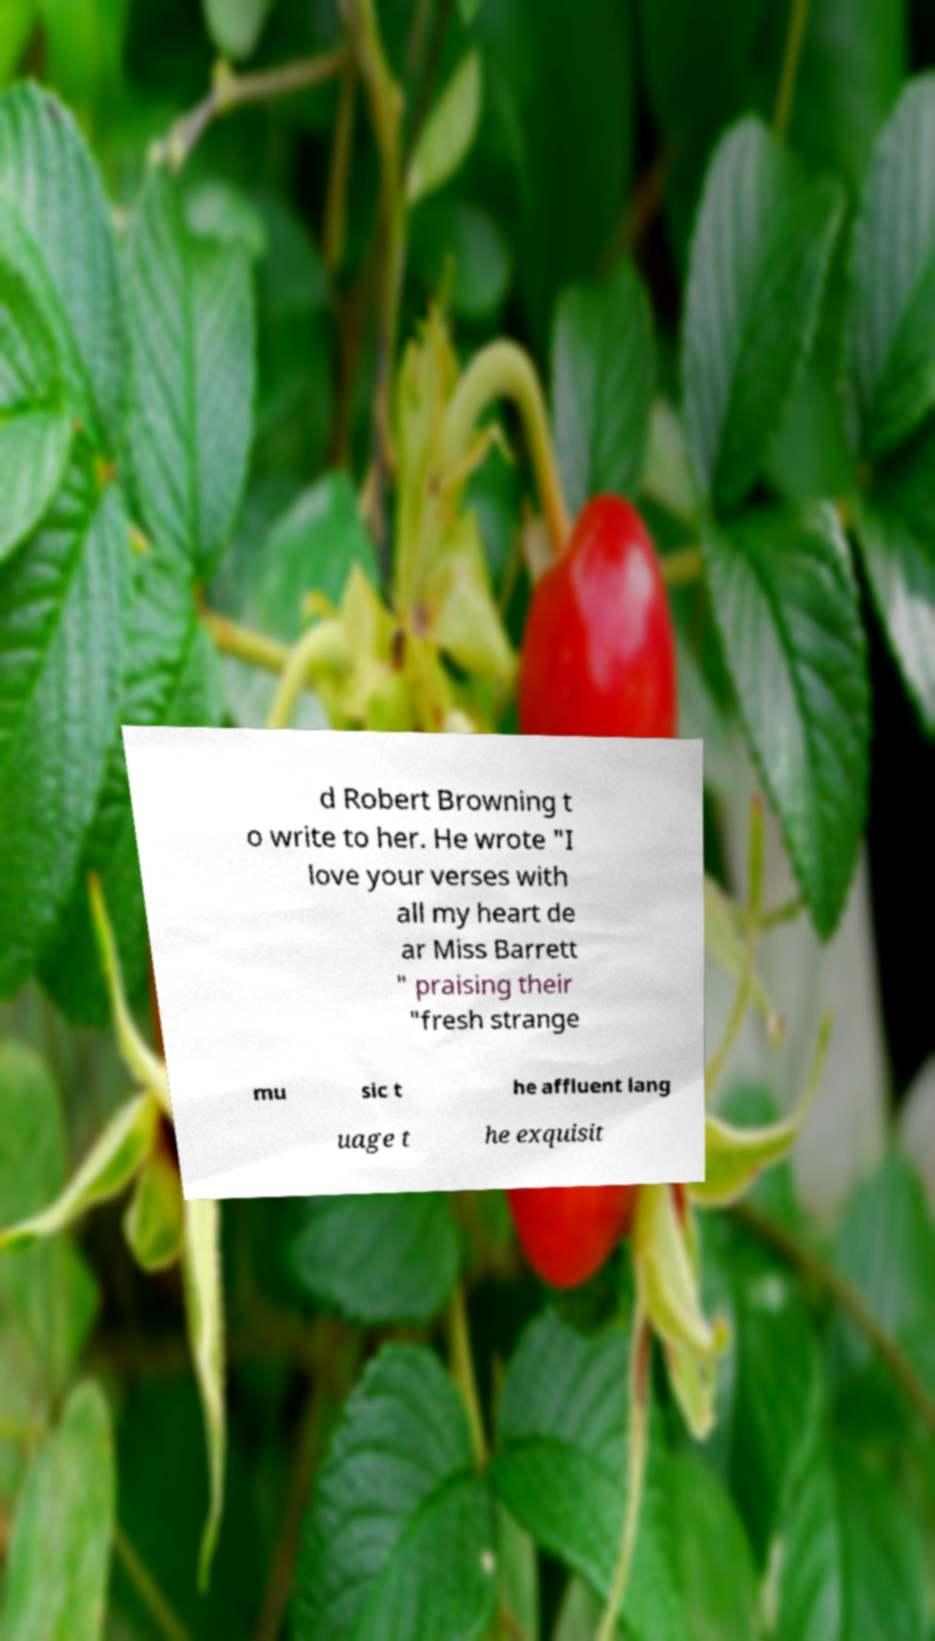Can you read and provide the text displayed in the image?This photo seems to have some interesting text. Can you extract and type it out for me? d Robert Browning t o write to her. He wrote "I love your verses with all my heart de ar Miss Barrett " praising their "fresh strange mu sic t he affluent lang uage t he exquisit 